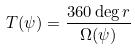Convert formula to latex. <formula><loc_0><loc_0><loc_500><loc_500>T ( \psi ) = \frac { 3 6 0 \deg r } { \Omega ( \psi ) }</formula> 